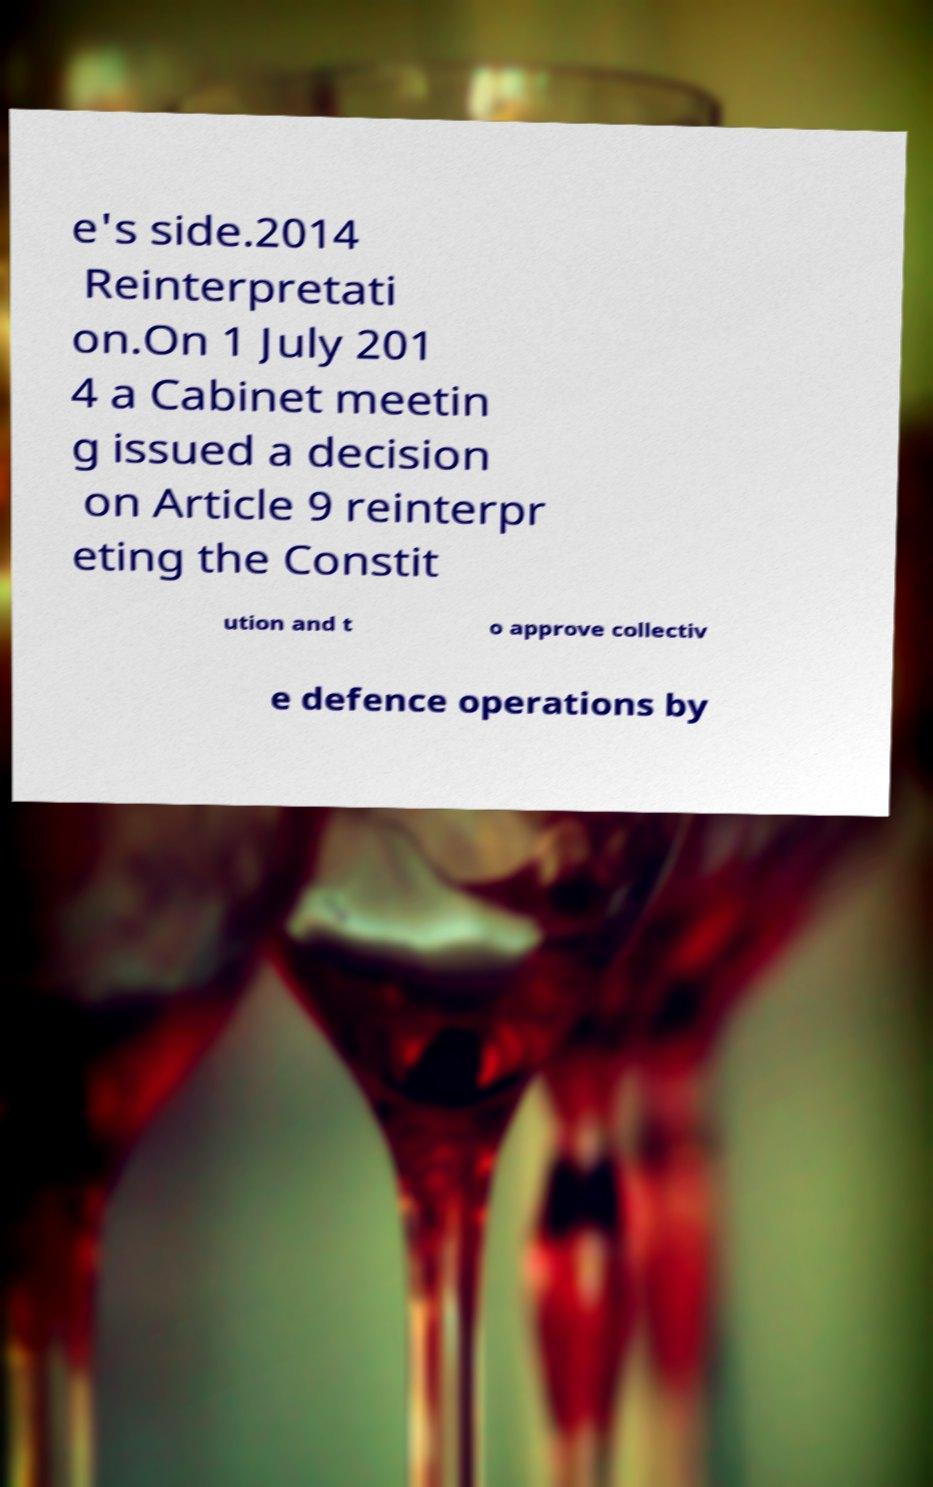Could you assist in decoding the text presented in this image and type it out clearly? e's side.2014 Reinterpretati on.On 1 July 201 4 a Cabinet meetin g issued a decision on Article 9 reinterpr eting the Constit ution and t o approve collectiv e defence operations by 